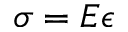Convert formula to latex. <formula><loc_0><loc_0><loc_500><loc_500>\sigma = E \epsilon</formula> 